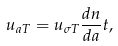<formula> <loc_0><loc_0><loc_500><loc_500>u _ { a T } = u _ { \sigma T } \frac { d n } { d a } t ,</formula> 